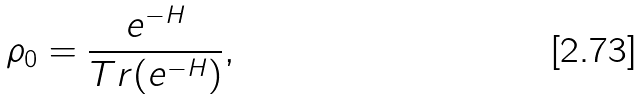Convert formula to latex. <formula><loc_0><loc_0><loc_500><loc_500>\rho _ { 0 } = \frac { e ^ { - H } } { T r ( e ^ { - H } ) } ,</formula> 